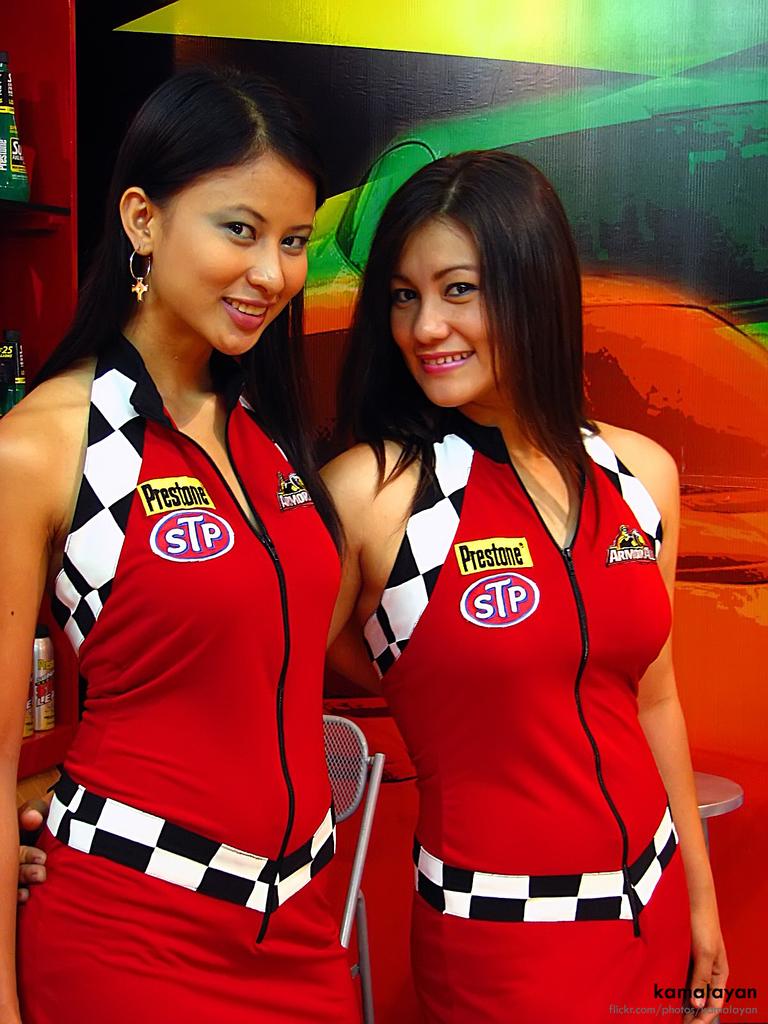What company is on their uniforms?
Give a very brief answer. Stp. What three letter company is on their uniforms?
Make the answer very short. Stp. 